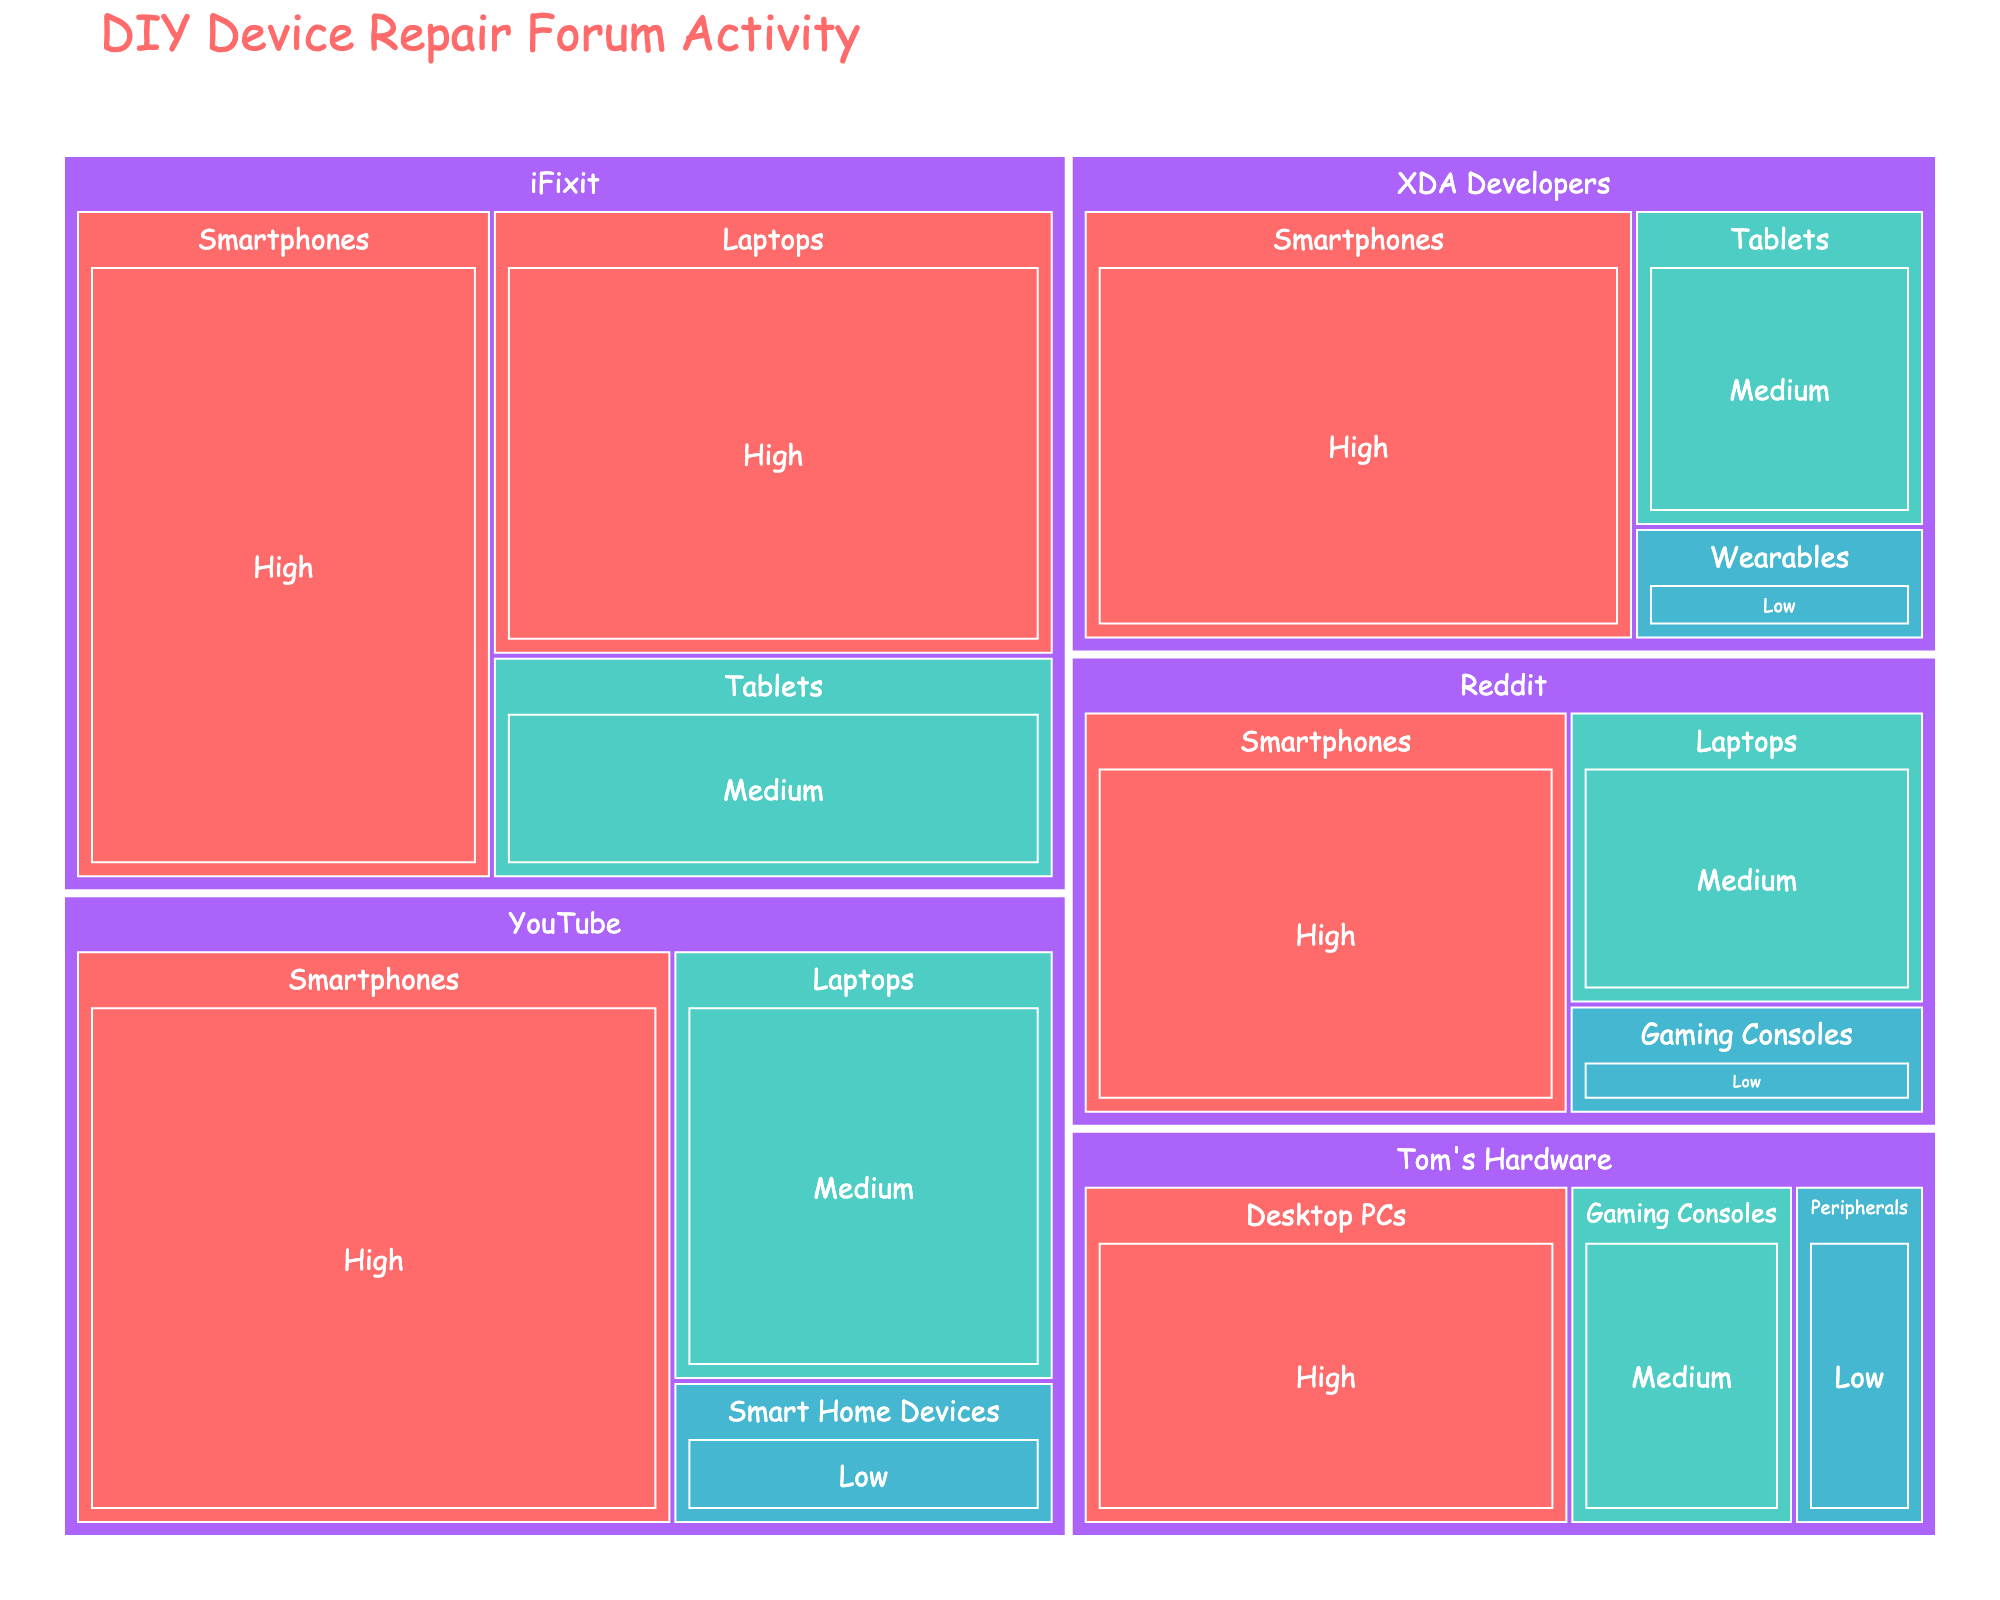Which platform has the highest user engagement for smartphones? Inspect the treemap and focus on the "Smartphones" category across different platforms. Compare the values of user engagement. The platform with the highest user engagement in this category is YouTube
Answer: YouTube How many platforms host discussion forums for laptops? Count the unique platforms that contain a "Laptops" category. The platforms are Reddit, iFixit, and YouTube.
Answer: Three Which device type has the lowest user engagement level on Reddit? Navigate to the "Reddit" branch and identify different device types. Locate the device type with the smallest value. The smallest value is for "Gaming Consoles".
Answer: Gaming Consoles What is the combined user engagement for high activity on iFixit? Go to the iFixit branch and find the values for high user engagement. Add these values together: 200 (Smartphones) + 180 (Laptops). The total is 380.
Answer: 380 Compare the high user engagement between YouTube and Tom's Hardware. Which one is higher and by how much? Locate the "High" user engagement values for YouTube and Tom's Hardware. YouTube has a value of 250 for "Smartphones", and Tom's Hardware has a value of 130 for "Desktop PCs". Calculate the difference: 250 - 130. The difference is 120, with YouTube being higher.
Answer: YouTube by 120 What is the average user engagement for the "Medium" category across all platforms? Find all "Medium" user engagements across the platforms. The values are: 80 (Reddit), 90 (iFixit), 120 (YouTube), 70 (XDA Developers), and 60 (Tom's Hardware). Sum these values: 80 + 90 + 120 + 70 + 60 = 420. Divide by the number of values, 420 / 5 = 84.
Answer: 84 What are the unique colors used to represent the different user engagement levels? Check the treemap legend for the colors assigned to each user engagement level. The unique colors are associated with high, medium, and low user engagement: red, teal, and light blue.
Answer: Red, teal, light blue Which device type does not appear under the XDA Developers platform? Look at the XDA Developers branch. The device types listed are Smartphones, Tablets, and Wearables. Identify the device types from the dataset that are absent in this branch.
Answer: Laptops, Gaming Consoles, Desktop PCs, Peripherals, Smart Home Devices What is the smallest value observed in any category, and which platform and device type does it belong to? Identify the smallest value from the treemap. Locate the smallest numerical value, which is 25 for Wearables on XDA Developers.
Answer: 25, XDA Developers, Wearables 